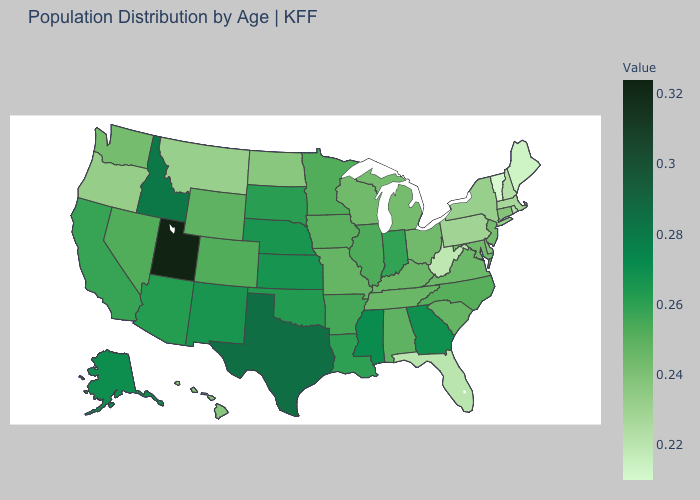Does California have a lower value than Mississippi?
Keep it brief. Yes. Among the states that border Colorado , which have the lowest value?
Short answer required. Wyoming. Among the states that border Delaware , does Maryland have the highest value?
Be succinct. Yes. Which states have the lowest value in the South?
Concise answer only. West Virginia. 